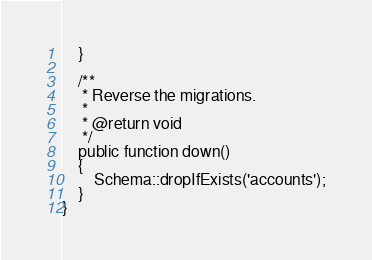Convert code to text. <code><loc_0><loc_0><loc_500><loc_500><_PHP_>    }

    /**
     * Reverse the migrations.
     *
     * @return void
     */
    public function down()
    {
        Schema::dropIfExists('accounts');
    }
}
</code> 